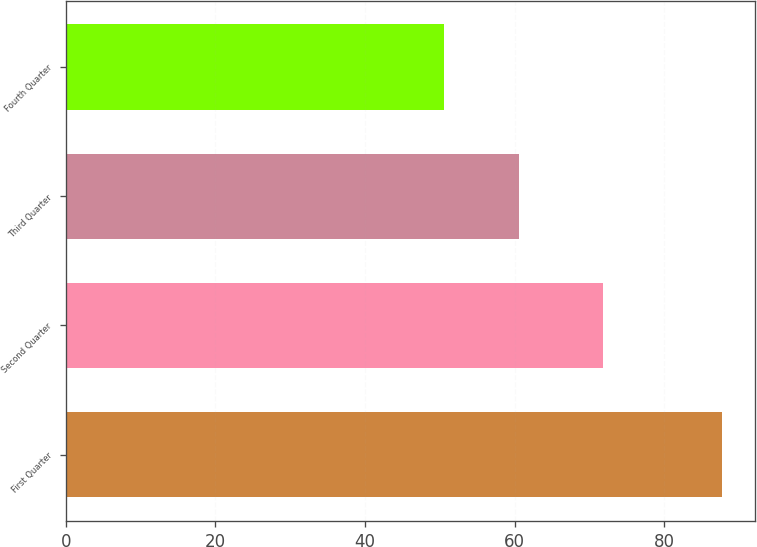<chart> <loc_0><loc_0><loc_500><loc_500><bar_chart><fcel>First Quarter<fcel>Second Quarter<fcel>Third Quarter<fcel>Fourth Quarter<nl><fcel>87.7<fcel>71.76<fcel>60.5<fcel>50.55<nl></chart> 